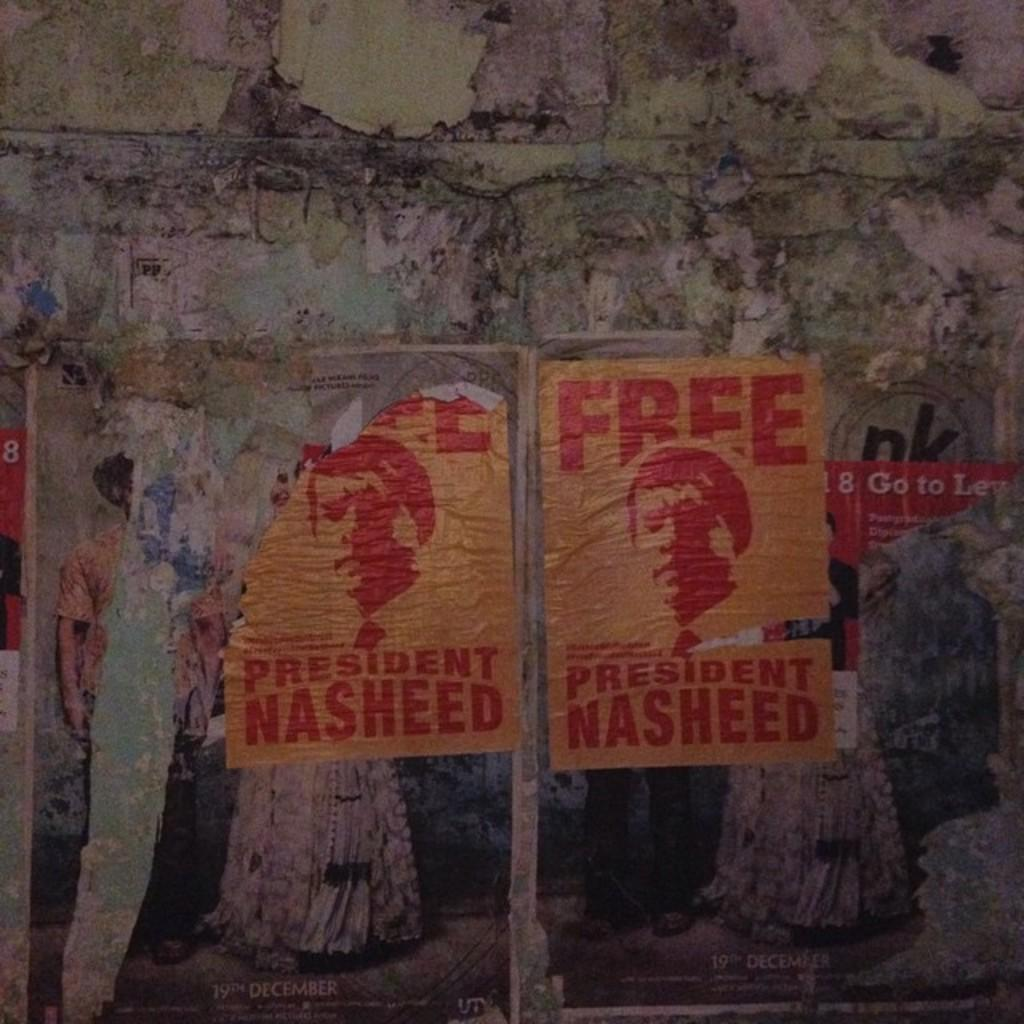<image>
Relay a brief, clear account of the picture shown. The tattered posters on the wall ask for the president to be freed. 